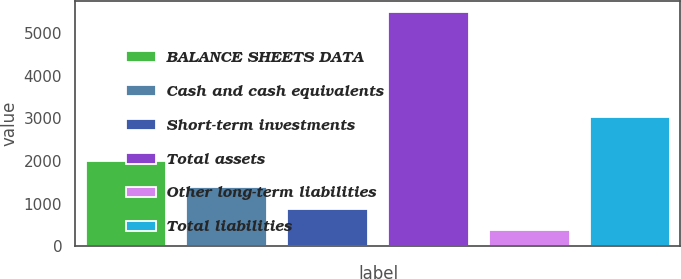Convert chart to OTSL. <chart><loc_0><loc_0><loc_500><loc_500><bar_chart><fcel>BALANCE SHEETS DATA<fcel>Cash and cash equivalents<fcel>Short-term investments<fcel>Total assets<fcel>Other long-term liabilities<fcel>Total liabilities<nl><fcel>2012<fcel>1397.4<fcel>885.7<fcel>5491<fcel>374<fcel>3033<nl></chart> 